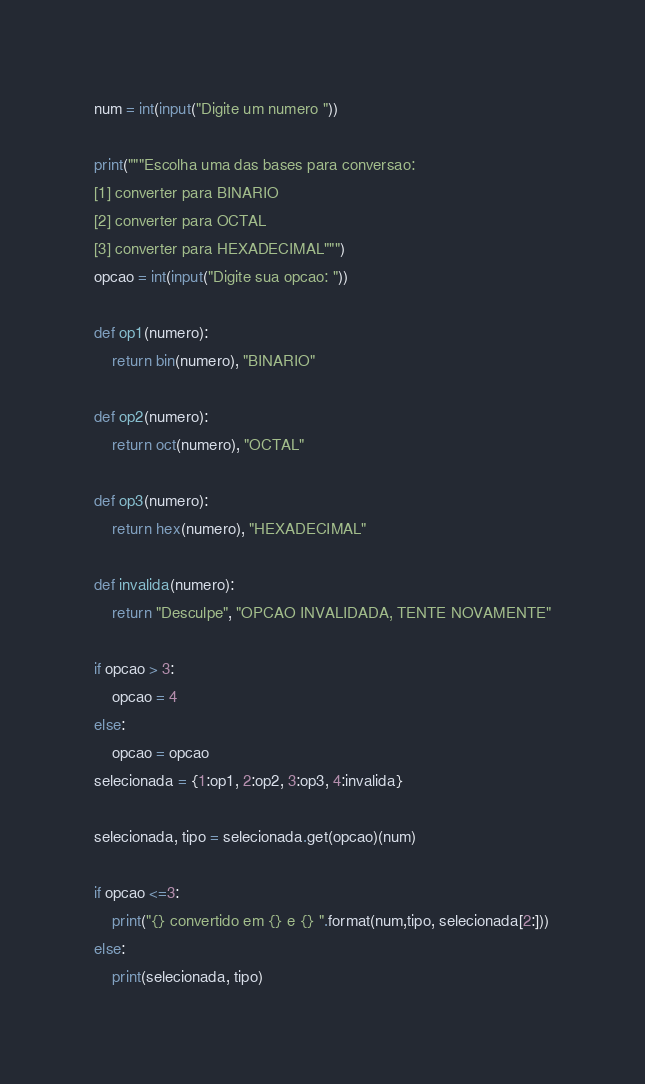<code> <loc_0><loc_0><loc_500><loc_500><_Python_>num = int(input("Digite um numero "))

print("""Escolha uma das bases para conversao:
[1] converter para BINARIO
[2] converter para OCTAL
[3] converter para HEXADECIMAL""")
opcao = int(input("Digite sua opcao: "))

def op1(numero):
    return bin(numero), "BINARIO"

def op2(numero):
    return oct(numero), "OCTAL"

def op3(numero):
    return hex(numero), "HEXADECIMAL"

def invalida(numero):
    return "Desculpe", "OPCAO INVALIDADA, TENTE NOVAMENTE"

if opcao > 3:
    opcao = 4
else:
    opcao = opcao
selecionada = {1:op1, 2:op2, 3:op3, 4:invalida}

selecionada, tipo = selecionada.get(opcao)(num)

if opcao <=3:
    print("{} convertido em {} e {} ".format(num,tipo, selecionada[2:]))
else:
    print(selecionada, tipo)</code> 